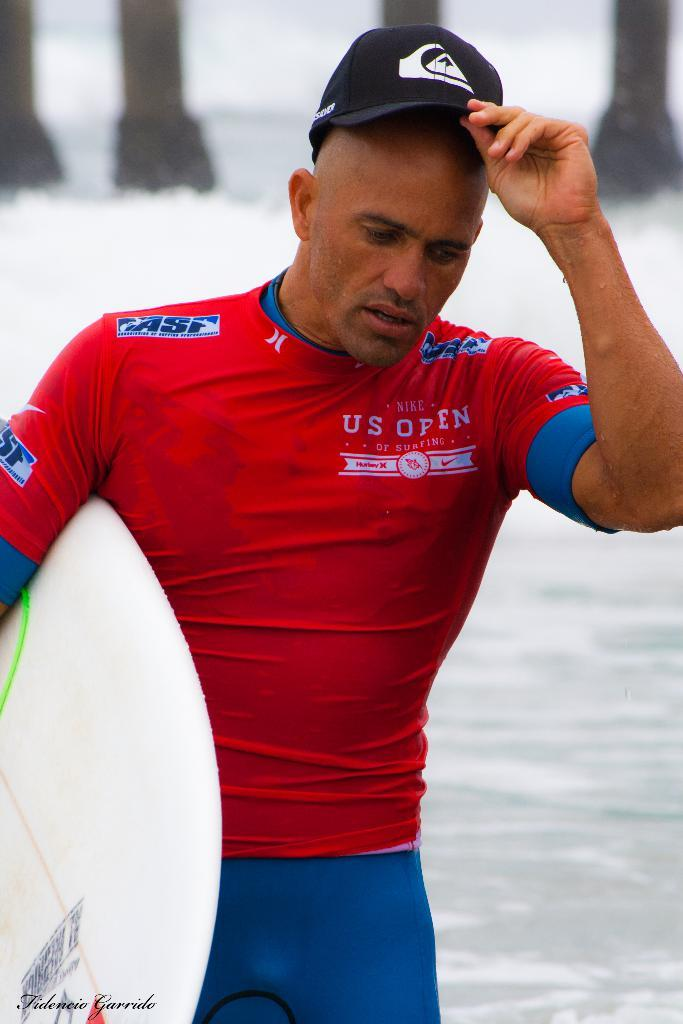<image>
Describe the image concisely. A man carrying a surfboard steps out of the water wearing a US Open shirt. 